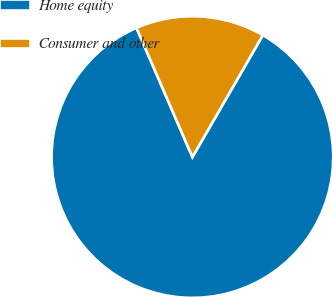Convert chart to OTSL. <chart><loc_0><loc_0><loc_500><loc_500><pie_chart><fcel>Home equity<fcel>Consumer and other<nl><fcel>85.16%<fcel>14.84%<nl></chart> 